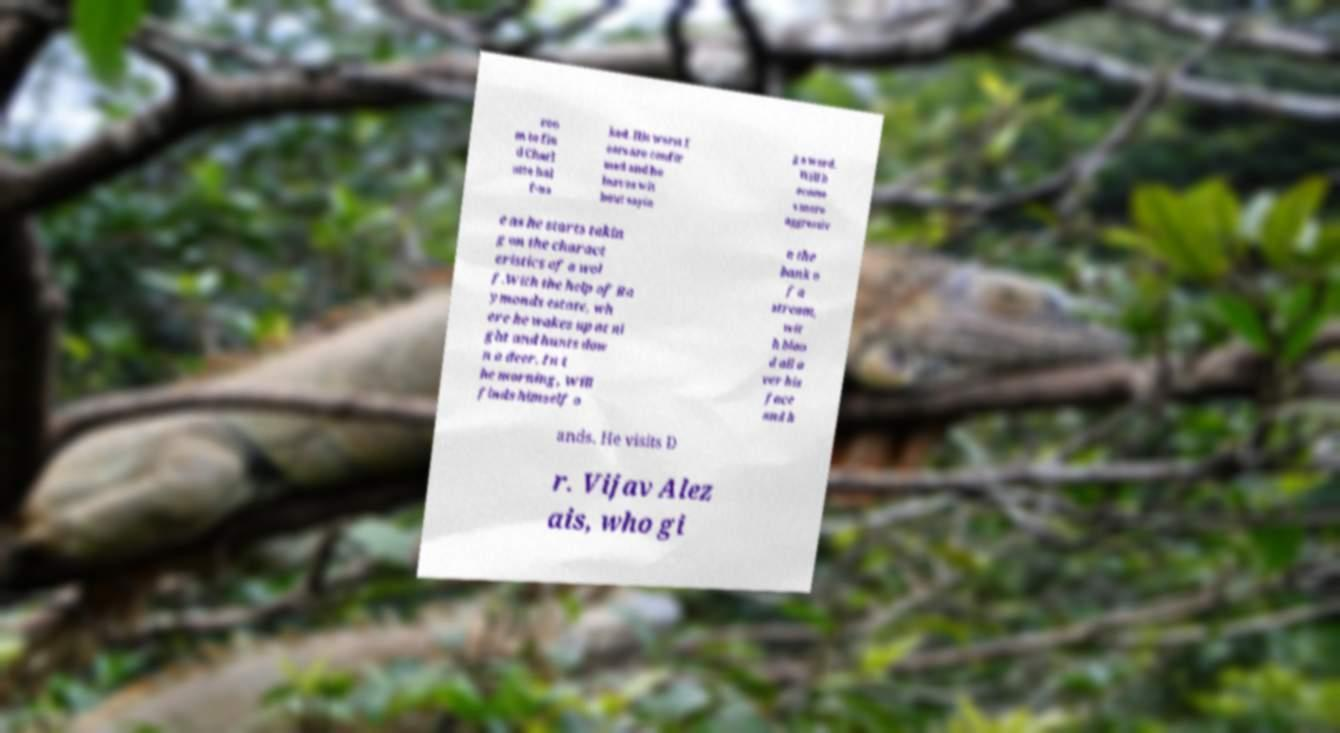Please identify and transcribe the text found in this image. roo m to fin d Charl otte hal f-na ked. His worst f ears are confir med and he leaves wit hout sayin g a word. Will b ecome s more aggressiv e as he starts takin g on the charact eristics of a wol f.With the help of Ra ymonds estate, wh ere he wakes up at ni ght and hunts dow n a deer. In t he morning, Will finds himself o n the bank o f a stream, wit h bloo d all o ver his face and h ands. He visits D r. Vijav Alez ais, who gi 